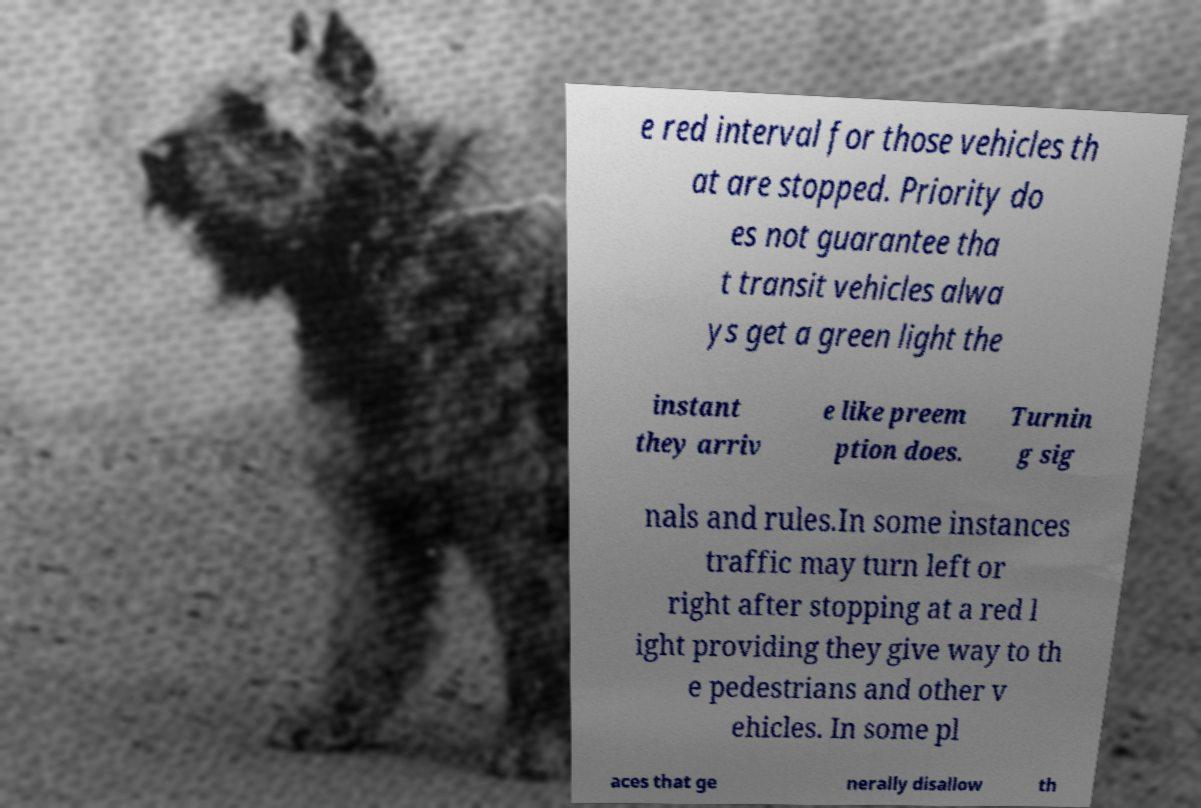For documentation purposes, I need the text within this image transcribed. Could you provide that? e red interval for those vehicles th at are stopped. Priority do es not guarantee tha t transit vehicles alwa ys get a green light the instant they arriv e like preem ption does. Turnin g sig nals and rules.In some instances traffic may turn left or right after stopping at a red l ight providing they give way to th e pedestrians and other v ehicles. In some pl aces that ge nerally disallow th 